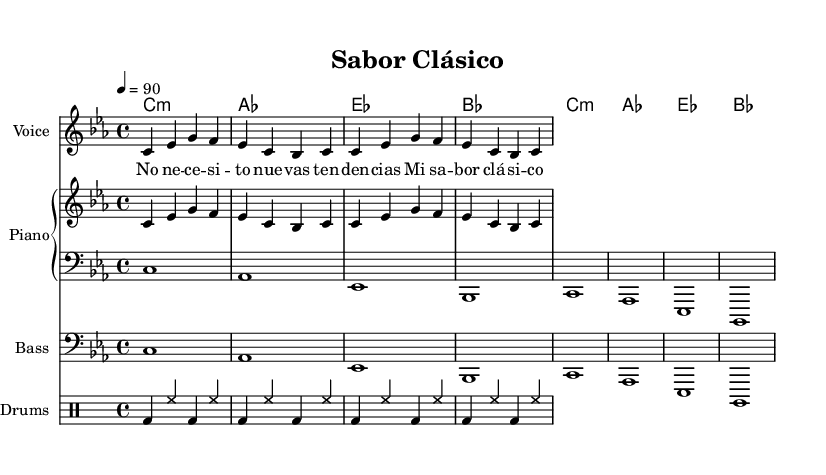What is the key signature of this music? The key signature is C minor, which has three flats (B flat, E flat, and A flat). This is indicated at the beginning of the staff.
Answer: C minor What is the time signature of this piece? The time signature is indicated as 4/4, which means there are four beats in each measure. This is shown at the beginning of the music.
Answer: 4/4 What is the tempo marking? The tempo marking indicates a tempo of quarter note equals 90, which tells musicians to play at this speed. This is shown at the start of the score.
Answer: 90 How many measures are in the melody? The melody has a total of 4 measures, which can be counted by looking at the grouping of notes and the vertical bar lines that separate them.
Answer: 4 What is the main theme expressed in the lyrics? The lyrics express a strong sentiment about staying true to classic flavors, emphasizing that it is their essence. This can be inferred from the repeated phrases in the text.
Answer: Classic flavors Which instrument is indicated for the melody? The melody is written for "Voice", as specified in the staff indication at the beginning.
Answer: Voice What type of drum beats are notated in the drum part? The drum part includes bass drum and hi-hat patterns, which are common in reggaeton music, indicated by the specific symbols in the drummode.
Answer: Bass drum and hi-hat 